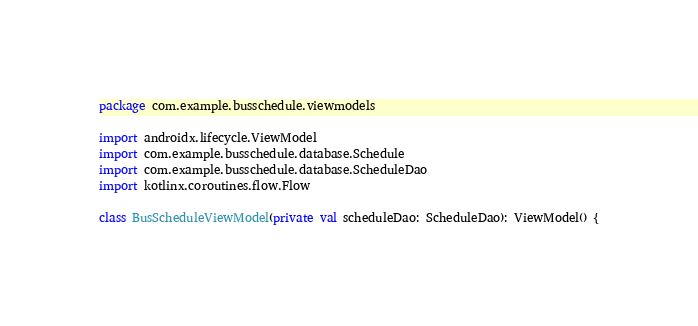<code> <loc_0><loc_0><loc_500><loc_500><_Kotlin_>package com.example.busschedule.viewmodels

import androidx.lifecycle.ViewModel
import com.example.busschedule.database.Schedule
import com.example.busschedule.database.ScheduleDao
import kotlinx.coroutines.flow.Flow

class BusScheduleViewModel(private val scheduleDao: ScheduleDao): ViewModel() {</code> 